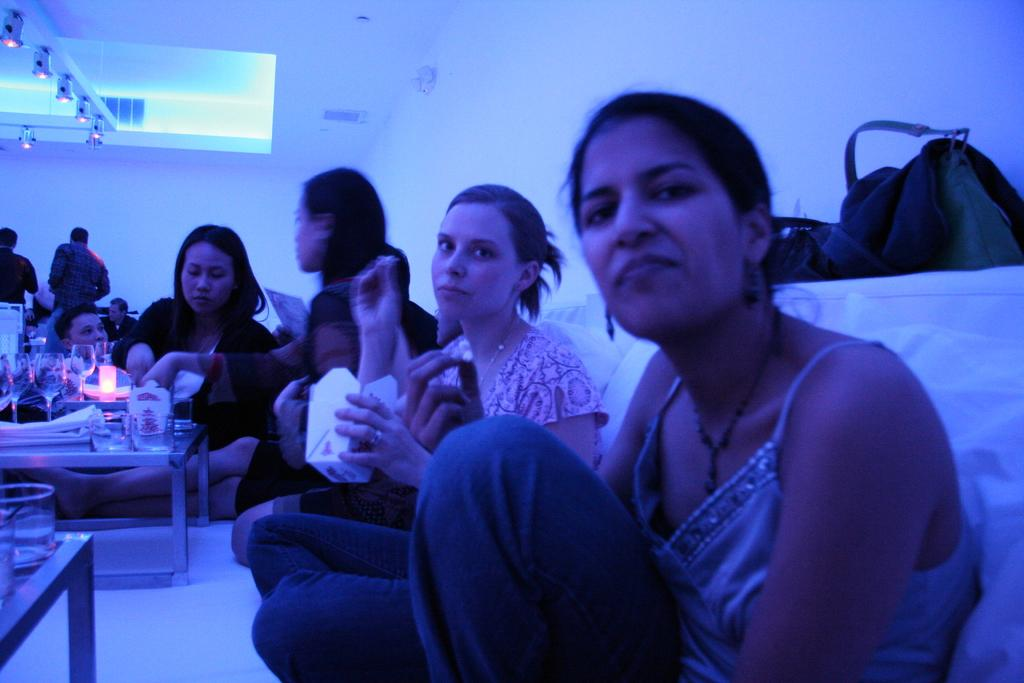What are the girls doing in the image? The girls are sitting on a sofa in the image. What is located in front of the sofa? There is a small table with food and glasses on it in front of the sofa. What can be seen on the ceiling in the image? There are lights on the ceiling in the image. What type of veil is draped over the sofa in the image? There is no veil present in the image; the girls are sitting on a sofa without any draped fabric. 